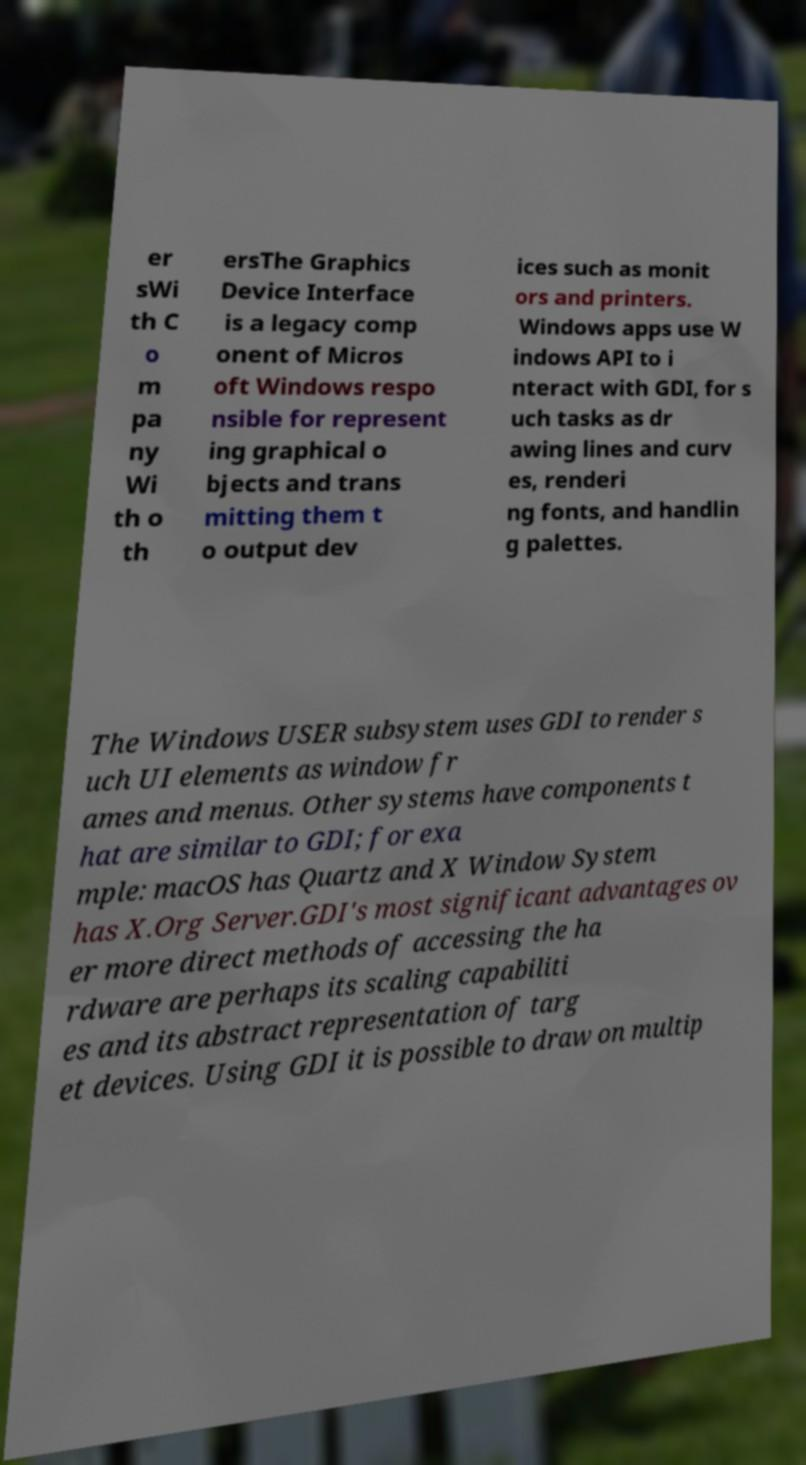Please read and relay the text visible in this image. What does it say? er sWi th C o m pa ny Wi th o th ersThe Graphics Device Interface is a legacy comp onent of Micros oft Windows respo nsible for represent ing graphical o bjects and trans mitting them t o output dev ices such as monit ors and printers. Windows apps use W indows API to i nteract with GDI, for s uch tasks as dr awing lines and curv es, renderi ng fonts, and handlin g palettes. The Windows USER subsystem uses GDI to render s uch UI elements as window fr ames and menus. Other systems have components t hat are similar to GDI; for exa mple: macOS has Quartz and X Window System has X.Org Server.GDI's most significant advantages ov er more direct methods of accessing the ha rdware are perhaps its scaling capabiliti es and its abstract representation of targ et devices. Using GDI it is possible to draw on multip 